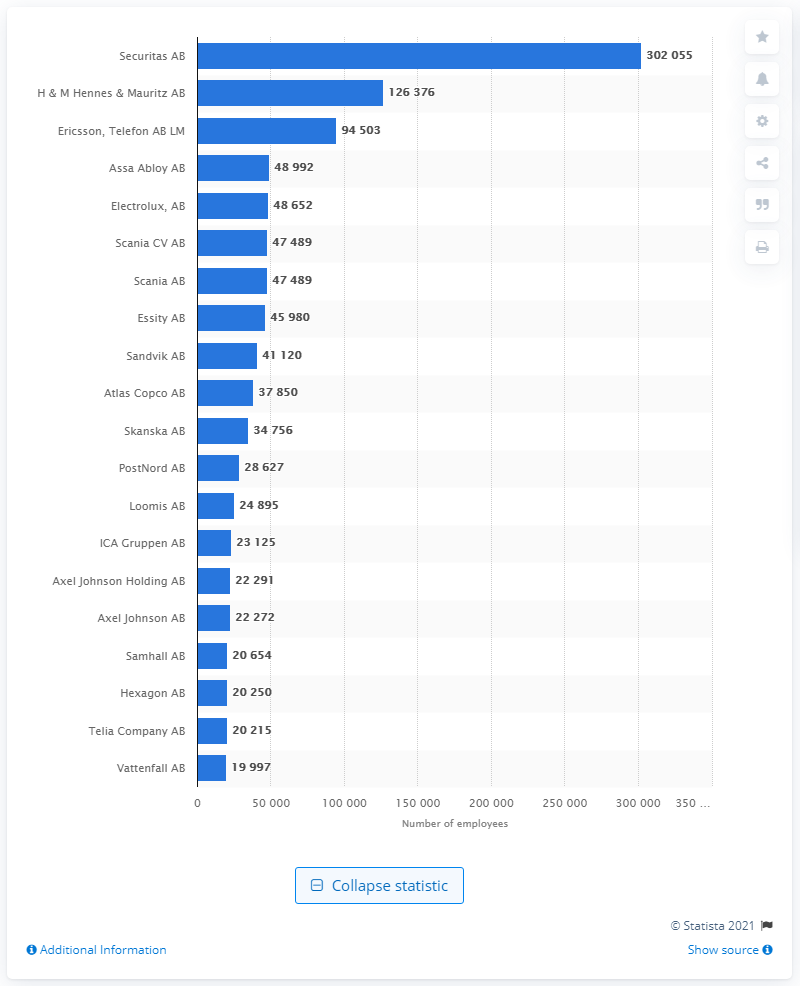Identify some key points in this picture. In 2021, the number of people who worked for Securitas was 30,205. The largest employer in Stockholm in 2021 was Securitas AB. In 2021, Ericsson had approximately 302,055 employees. 